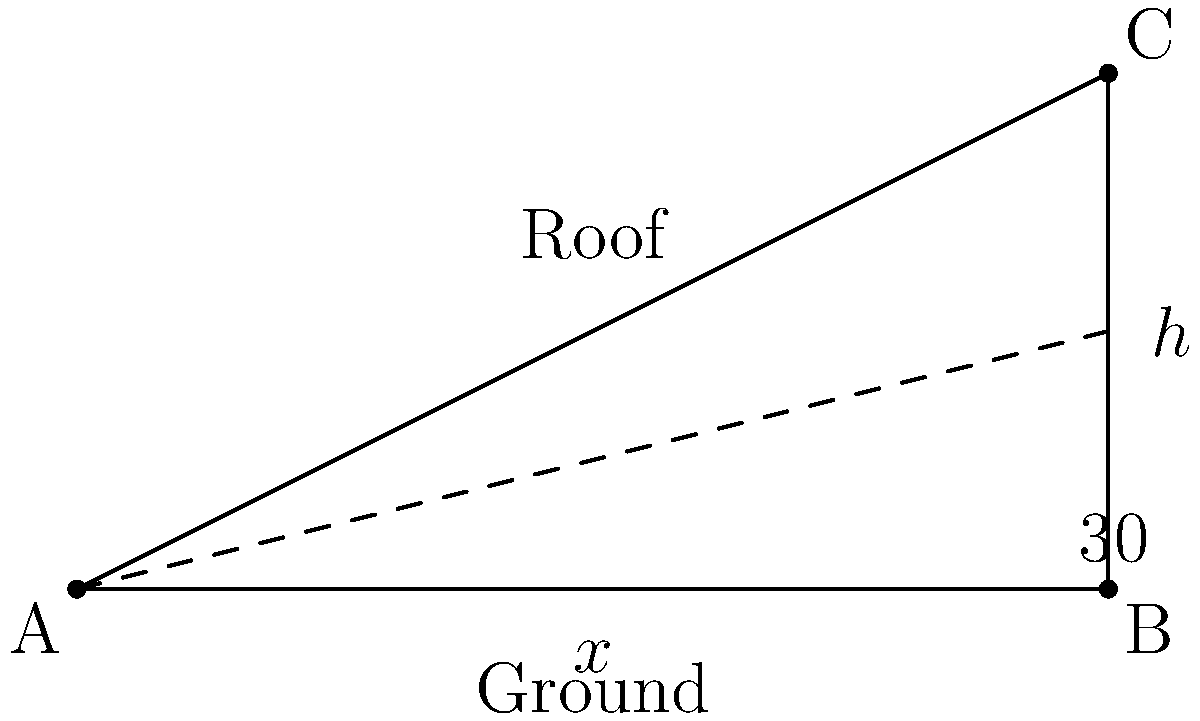A rainwater harvesting system needs to be installed on a sloped roof in a rural Ugandan village. The roof has a horizontal span of 10 meters and a height of 5 meters at its peak. To maximize water collection, the system should be installed at an angle perpendicular to the roof's surface. What is the optimal angle (in degrees) for the rainwater harvesting system relative to the horizontal ground? Let's approach this step-by-step:

1) First, we need to find the angle of the roof relative to the horizontal ground. We can do this using the trigonometric ratio tangent.

2) In the right triangle formed by the roof:
   - The opposite side (height) is 5 meters
   - The adjacent side (horizontal span) is 10 meters

3) The tangent of the roof angle is:
   $$\tan(\theta) = \frac{\text{opposite}}{\text{adjacent}} = \frac{5}{10} = 0.5$$

4) To find the angle, we take the inverse tangent (arctan):
   $$\theta = \arctan(0.5) \approx 26.57°$$

5) This is the angle of the roof relative to the horizontal ground.

6) For the rainwater harvesting system to be perpendicular to the roof surface, it needs to be at a 90° angle to the roof.

7) Therefore, the optimal angle for the system relative to the horizontal ground is:
   $$90° - 26.57° = 63.43°$$

8) Rounding to the nearest degree:
   $$63.43° \approx 63°$$
Answer: 63° 